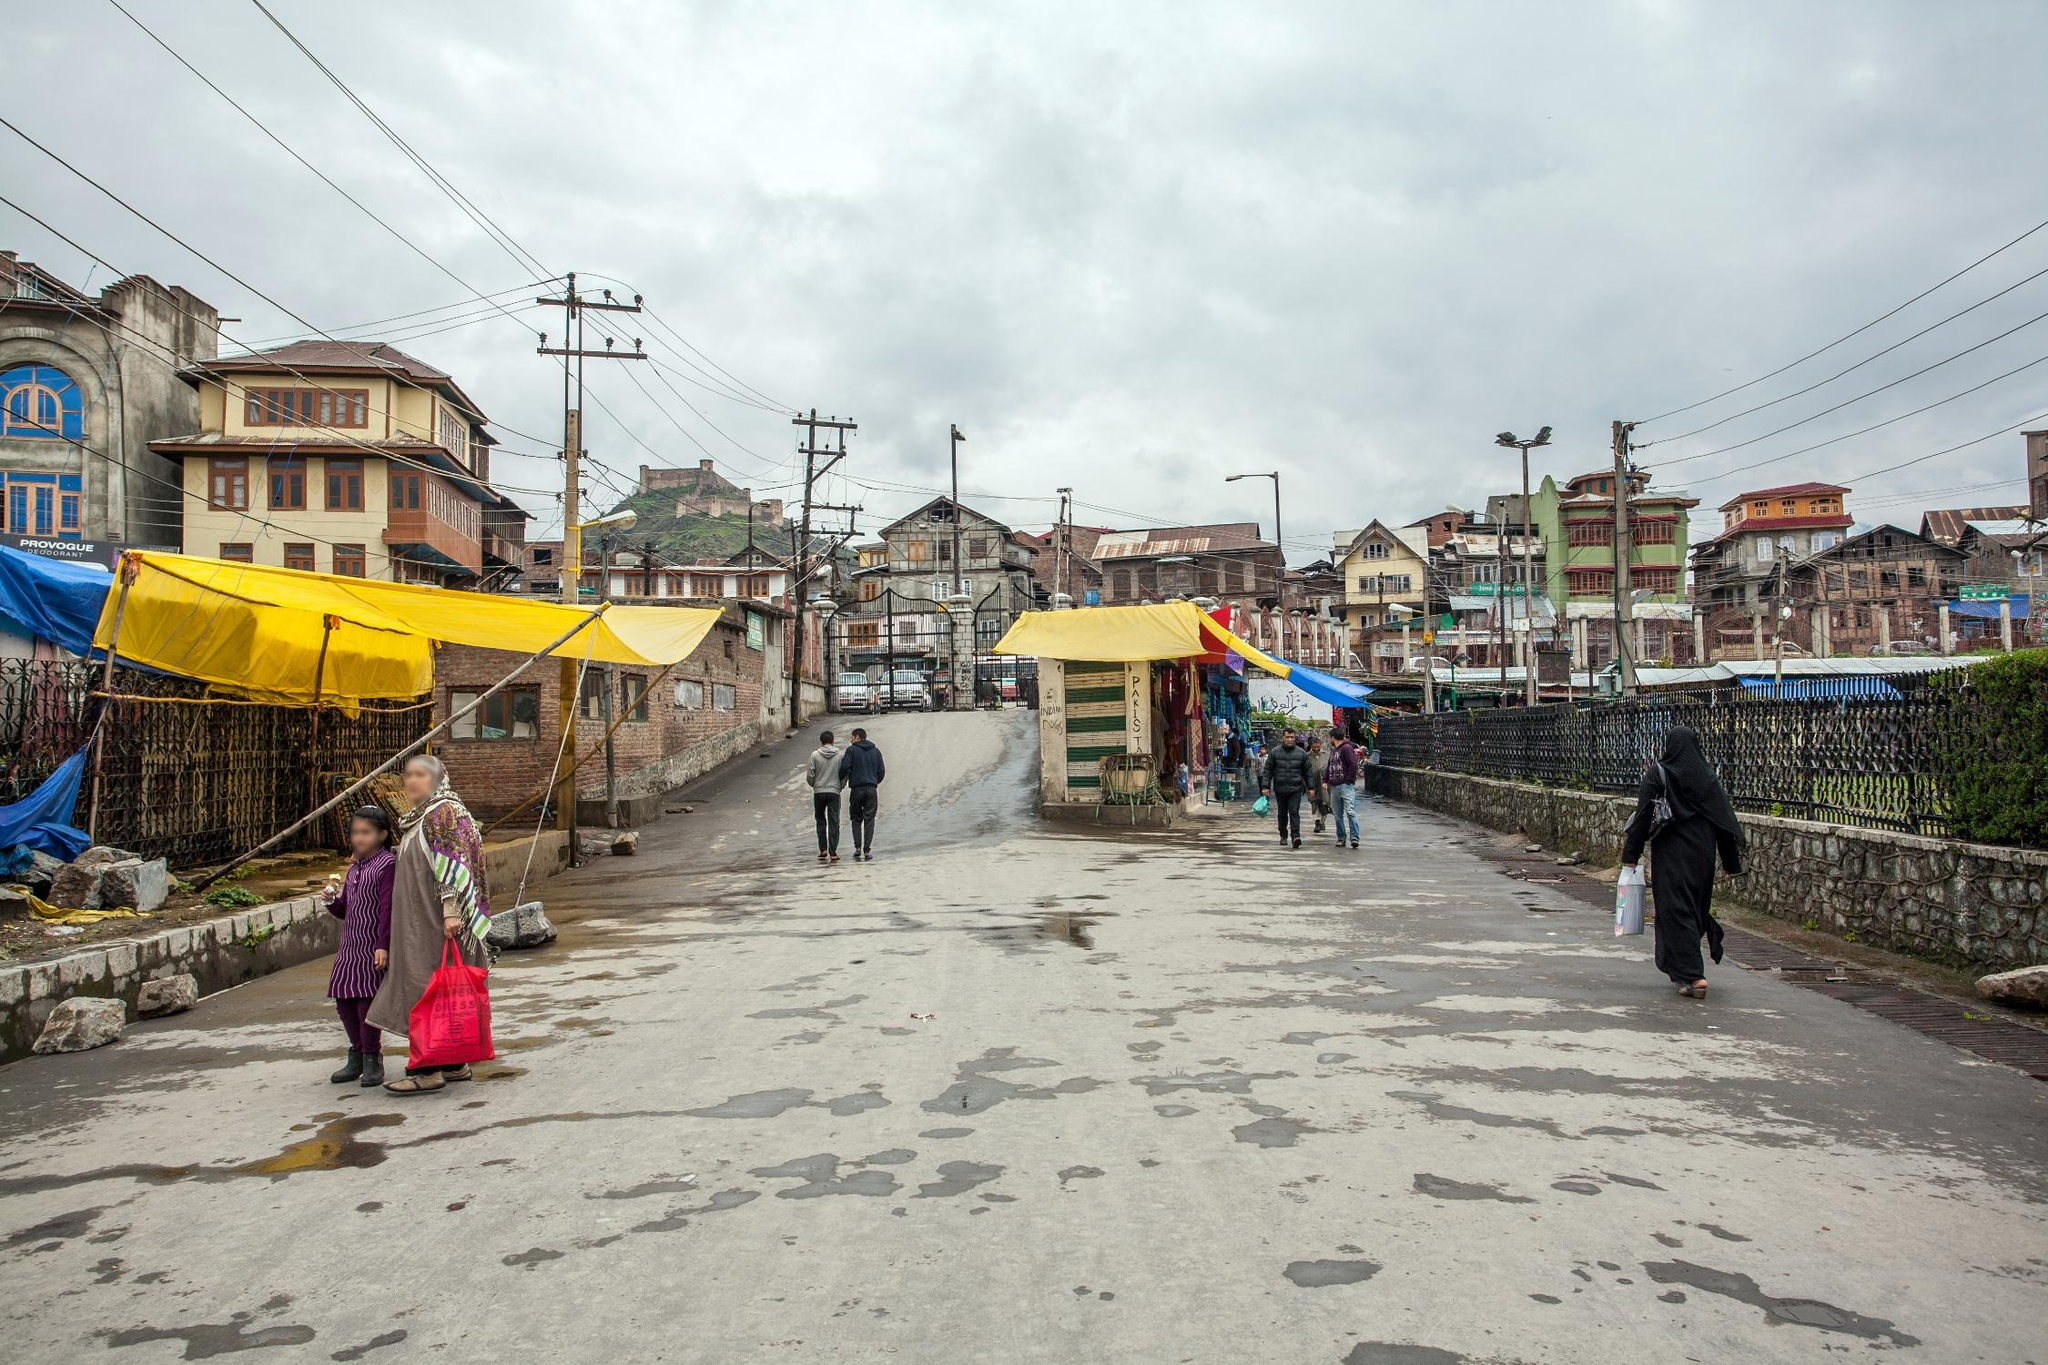Describe a possible casual encounter on this street. A possible casual encounter on this street could involve two old friends running into each other near one of the market stalls. They might exchange warm greetings, catch up on old times, and discuss latest updates in their lives. Nearby, a street vendor selling hot tea might offer them a cup to warm their hands against the chill of the gray day. Write a dialogue of a person explaining their day after this casual encounter. Person 1: 'Guess who I bumped into today? Raj! We were just walking past the spice stall, and we both stopped at the sharegpt4v/same time. It’s been years since we last met.' 
Person 2: 'That's amazing! Did you talk for long?' 
Person 1: 'Yeah, we stood by the tea vendor for a good while, reminiscing about school days and sharing what we're up to now. Despite the dreary weather, catching up with him really brightened my day!' 